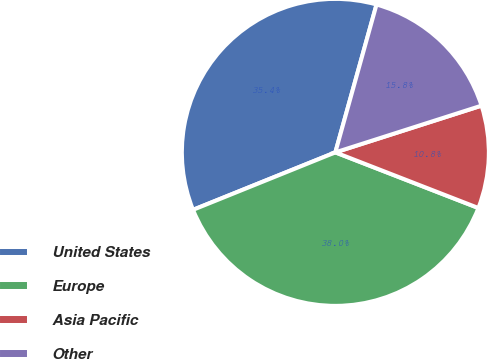Convert chart to OTSL. <chart><loc_0><loc_0><loc_500><loc_500><pie_chart><fcel>United States<fcel>Europe<fcel>Asia Pacific<fcel>Other<nl><fcel>35.43%<fcel>37.99%<fcel>10.83%<fcel>15.75%<nl></chart> 